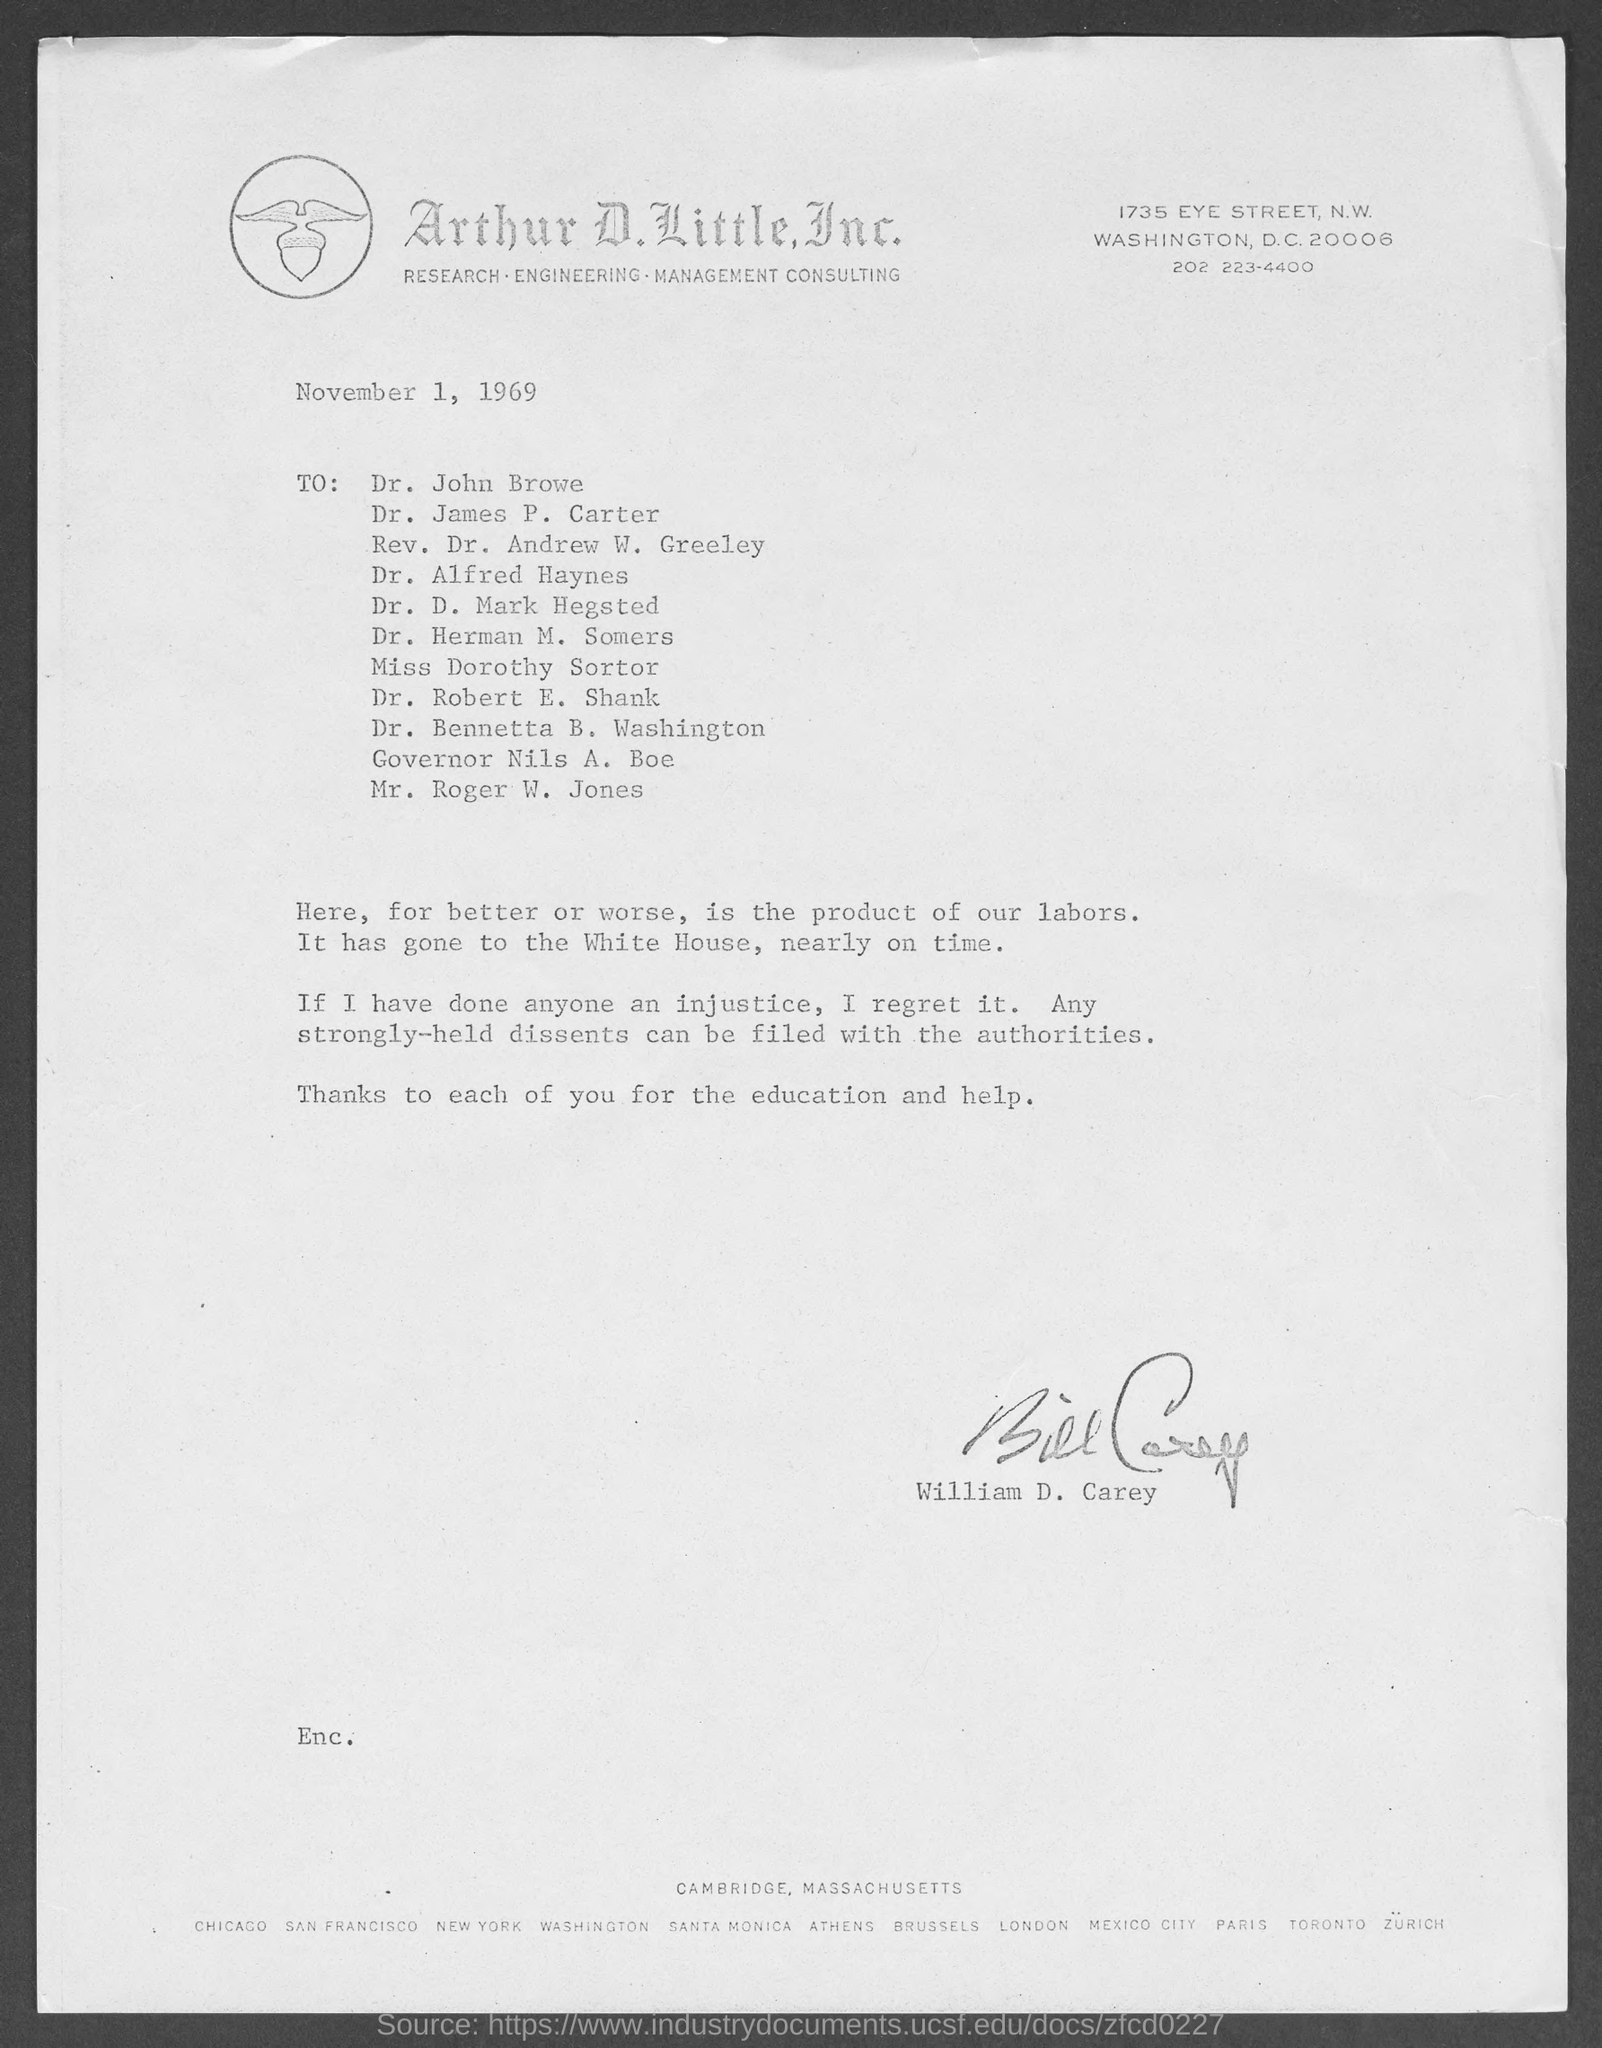What is the street address of arthur d. little, inc.?
Your response must be concise. 1735 Eye Street. What is the date above to address ?
Ensure brevity in your answer.  November 1, 1969. Who wrote this memorandum ?
Offer a terse response. William D. Carey. 